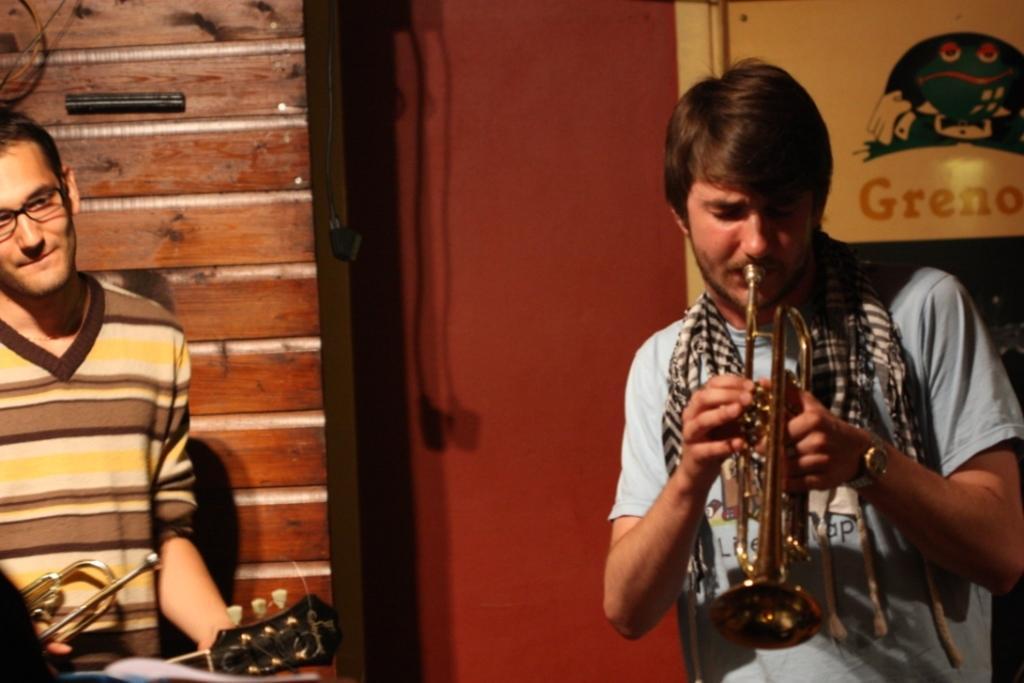Please provide a concise description of this image. In this picture we can see there are two men holding the musical instruments. Behind the people there is a door, wall and a board. 